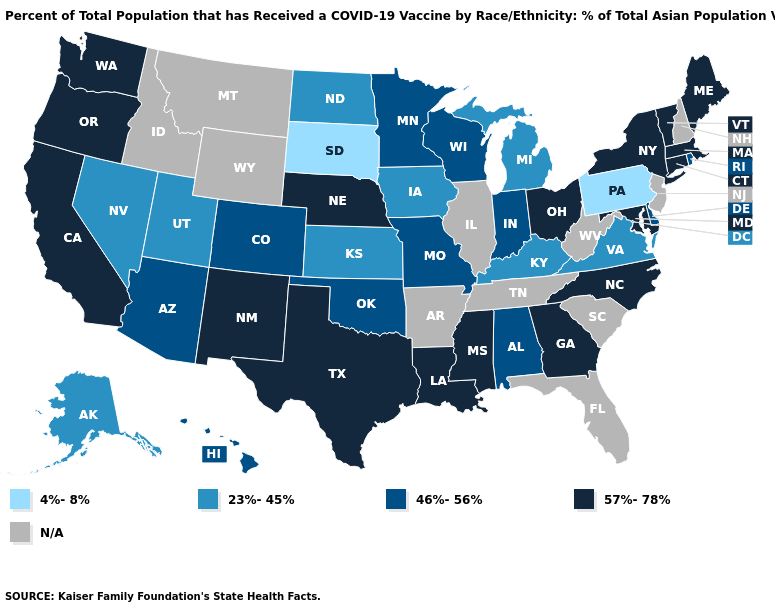Among the states that border Virginia , which have the highest value?
Write a very short answer. Maryland, North Carolina. Among the states that border Tennessee , does Mississippi have the lowest value?
Quick response, please. No. Among the states that border Illinois , does Iowa have the lowest value?
Write a very short answer. Yes. Does Alaska have the lowest value in the West?
Write a very short answer. Yes. What is the value of Nebraska?
Quick response, please. 57%-78%. Among the states that border Tennessee , which have the highest value?
Give a very brief answer. Georgia, Mississippi, North Carolina. Name the states that have a value in the range 46%-56%?
Keep it brief. Alabama, Arizona, Colorado, Delaware, Hawaii, Indiana, Minnesota, Missouri, Oklahoma, Rhode Island, Wisconsin. Among the states that border Idaho , does Nevada have the highest value?
Answer briefly. No. What is the value of Michigan?
Be succinct. 23%-45%. Which states hav the highest value in the MidWest?
Short answer required. Nebraska, Ohio. Among the states that border Massachusetts , does Rhode Island have the highest value?
Quick response, please. No. Does Arizona have the highest value in the West?
Be succinct. No. Does Michigan have the highest value in the USA?
Give a very brief answer. No. How many symbols are there in the legend?
Keep it brief. 5. 